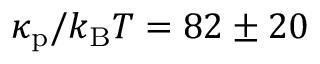Convert formula to latex. <formula><loc_0><loc_0><loc_500><loc_500>\kappa _ { p } / k _ { B } T = 8 2 \pm 2 0</formula> 